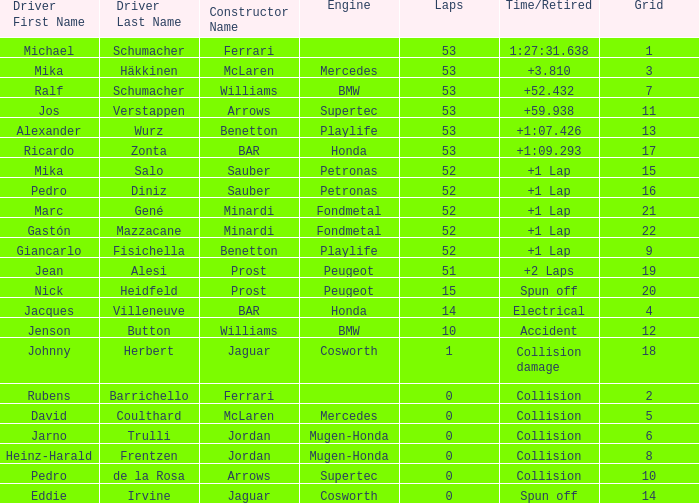How many laps were covered by ricardo zonta? 53.0. 